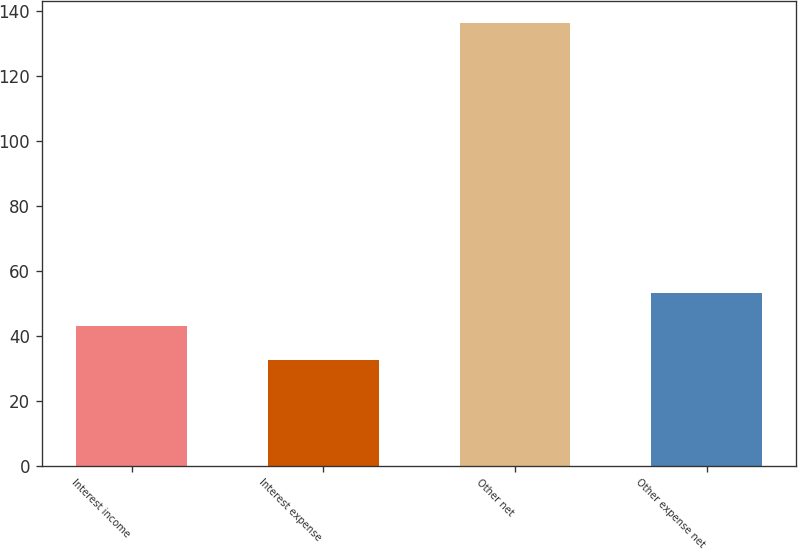<chart> <loc_0><loc_0><loc_500><loc_500><bar_chart><fcel>Interest income<fcel>Interest expense<fcel>Other net<fcel>Other expense net<nl><fcel>42.88<fcel>32.5<fcel>136.3<fcel>53.26<nl></chart> 